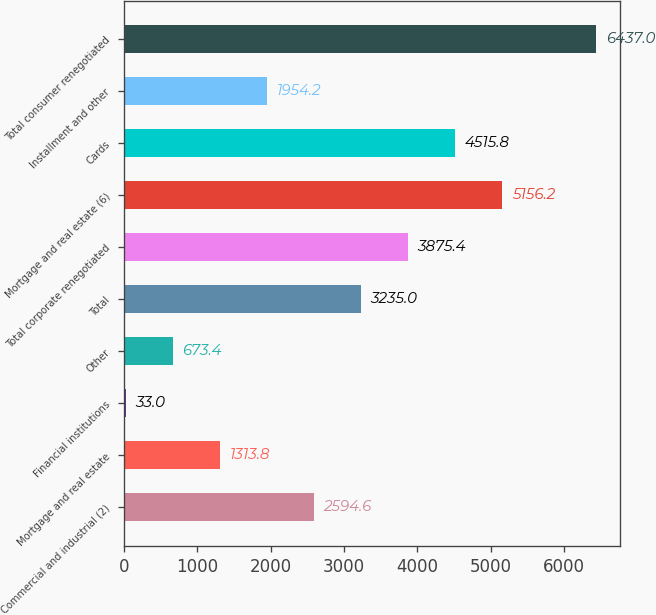<chart> <loc_0><loc_0><loc_500><loc_500><bar_chart><fcel>Commercial and industrial (2)<fcel>Mortgage and real estate<fcel>Financial institutions<fcel>Other<fcel>Total<fcel>Total corporate renegotiated<fcel>Mortgage and real estate (6)<fcel>Cards<fcel>Installment and other<fcel>Total consumer renegotiated<nl><fcel>2594.6<fcel>1313.8<fcel>33<fcel>673.4<fcel>3235<fcel>3875.4<fcel>5156.2<fcel>4515.8<fcel>1954.2<fcel>6437<nl></chart> 